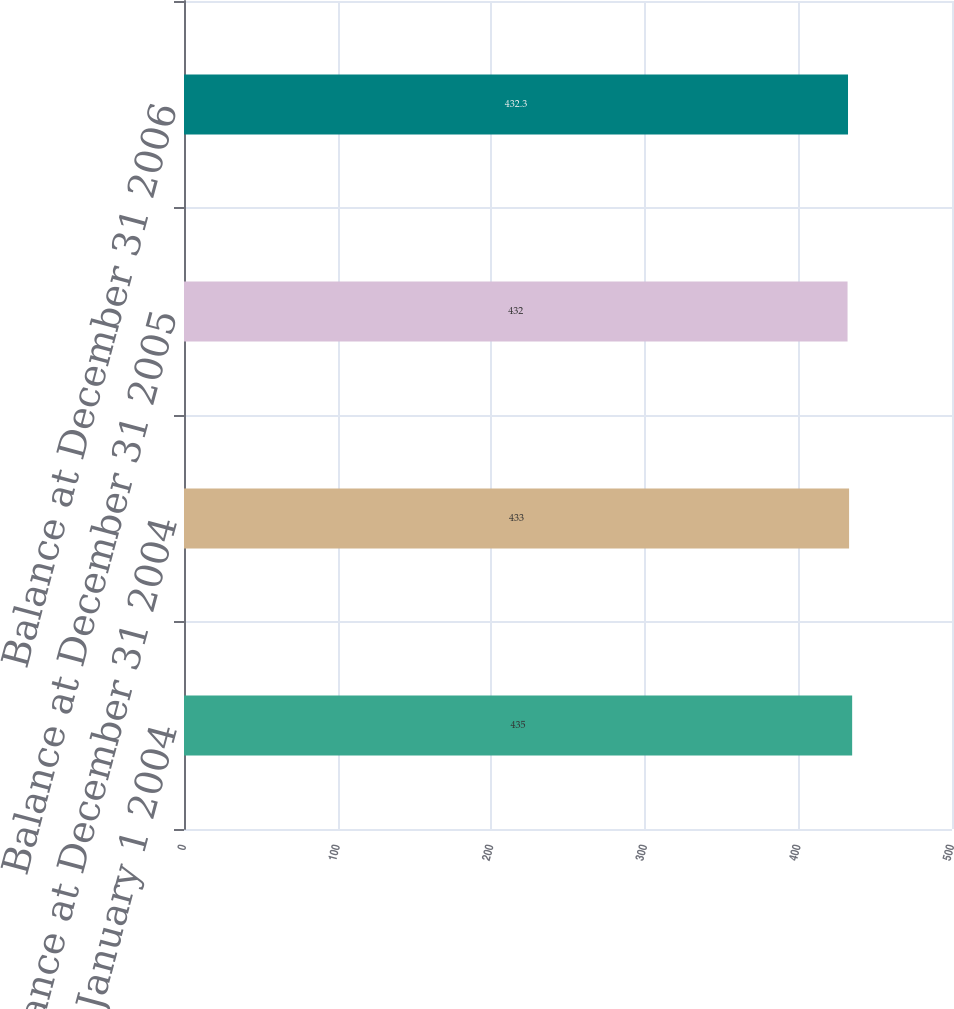Convert chart. <chart><loc_0><loc_0><loc_500><loc_500><bar_chart><fcel>Balance at January 1 2004<fcel>Balance at December 31 2004<fcel>Balance at December 31 2005<fcel>Balance at December 31 2006<nl><fcel>435<fcel>433<fcel>432<fcel>432.3<nl></chart> 